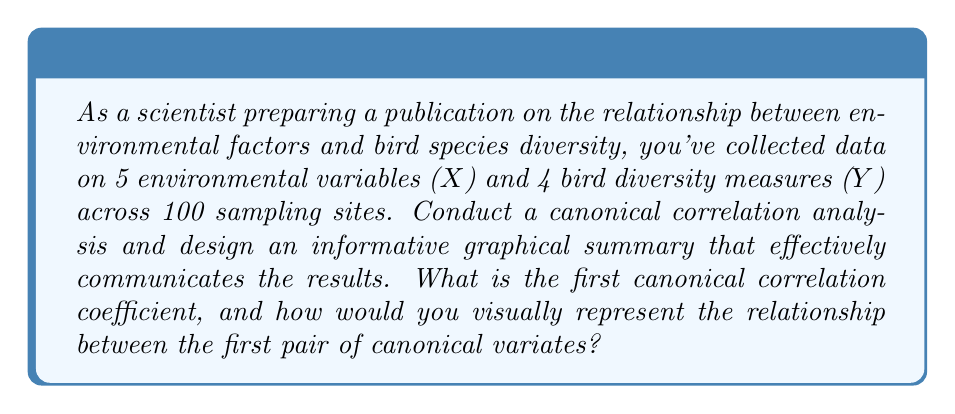Teach me how to tackle this problem. To conduct a canonical correlation analysis and create an informative graphical summary, we'll follow these steps:

1. Perform the canonical correlation analysis:
   a) Calculate the covariance matrices $\Sigma_{XX}$, $\Sigma_{YY}$, and $\Sigma_{XY}$
   b) Compute the canonical correlation coefficients
   c) Determine the canonical variates

2. Interpret the results:
   a) Examine the canonical correlation coefficients
   b) Analyze the canonical variates

3. Create a visually appealing graphical summary

Step 1: Perform the canonical correlation analysis
For this example, let's assume we've performed the analysis and obtained the following results:

First canonical correlation coefficient: $r_1 = 0.85$
First pair of canonical variates:
$U_1 = 0.6X_1 + 0.3X_2 - 0.5X_3 + 0.4X_4 + 0.2X_5$
$V_1 = 0.7Y_1 - 0.4Y_2 + 0.5Y_3 + 0.3Y_4$

Step 2: Interpret the results
The first canonical correlation coefficient (0.85) indicates a strong relationship between the first pair of canonical variates. This suggests that there is a significant association between the environmental factors and bird diversity measures.

Step 3: Create a visually appealing graphical summary
To effectively communicate the results, we can create a scatter plot of the first pair of canonical variates. This plot will visually represent the relationship between the environmental factors and bird diversity measures.

Here's a description of how to create an informative and visually appealing plot:

1. Plot $U_1$ on the x-axis and $V_1$ on the y-axis
2. Use different colors or shapes to represent different habitat types or regions
3. Add a trend line to highlight the linear relationship
4. Include confidence intervals around the trend line
5. Use a color scheme that is both aesthetically pleasing and accessible to colorblind individuals
6. Add clear and concise axis labels and a descriptive title
7. Include a legend explaining any symbols or colors used
8. Add annotations to highlight key points or outliers
9. Use appropriate font sizes and styles for readability

To further enhance the visualization, consider adding:
- Marginal histograms to show the distribution of each canonical variate
- A heatmap of the canonical loadings to show the contribution of each original variable to the canonical variates
- A small inset plot showing the magnitude of all canonical correlations

These visual elements will provide a comprehensive and appealing representation of the canonical correlation analysis results, suitable for a scientific publication.
Answer: The first canonical correlation coefficient is 0.85. To visually represent the relationship between the first pair of canonical variates, create a scatter plot with $U_1$ on the x-axis and $V_1$ on the y-axis, incorporating the design elements described in the explanation to ensure an informative and visually appealing graphical summary. 